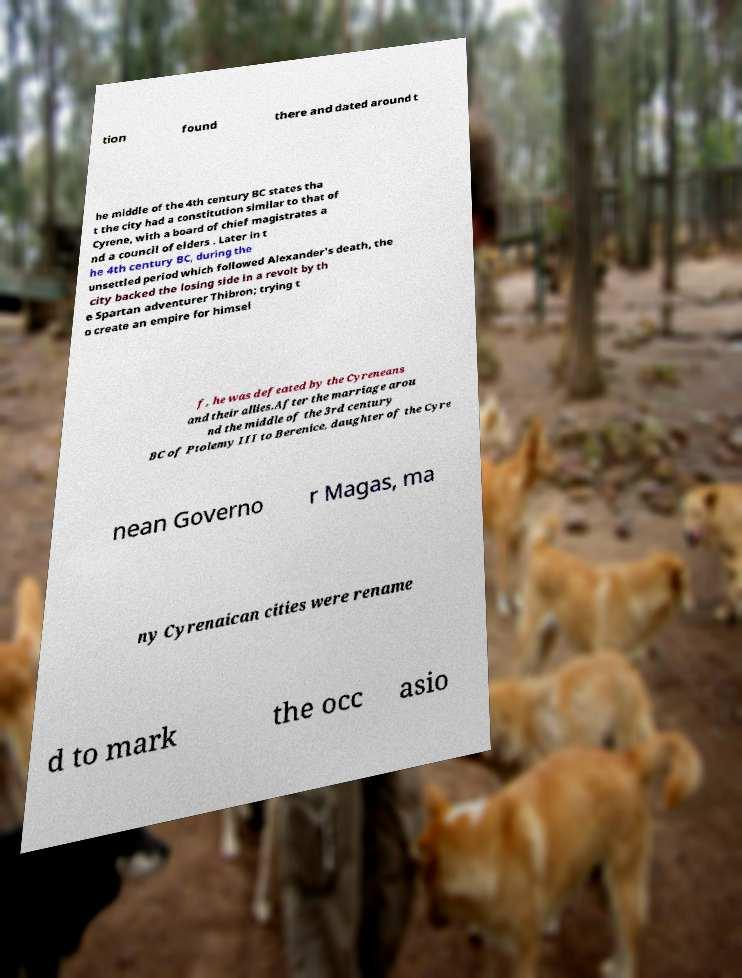Could you assist in decoding the text presented in this image and type it out clearly? tion found there and dated around t he middle of the 4th century BC states tha t the city had a constitution similar to that of Cyrene, with a board of chief magistrates a nd a council of elders . Later in t he 4th century BC, during the unsettled period which followed Alexander's death, the city backed the losing side in a revolt by th e Spartan adventurer Thibron; trying t o create an empire for himsel f, he was defeated by the Cyreneans and their allies.After the marriage arou nd the middle of the 3rd century BC of Ptolemy III to Berenice, daughter of the Cyre nean Governo r Magas, ma ny Cyrenaican cities were rename d to mark the occ asio 